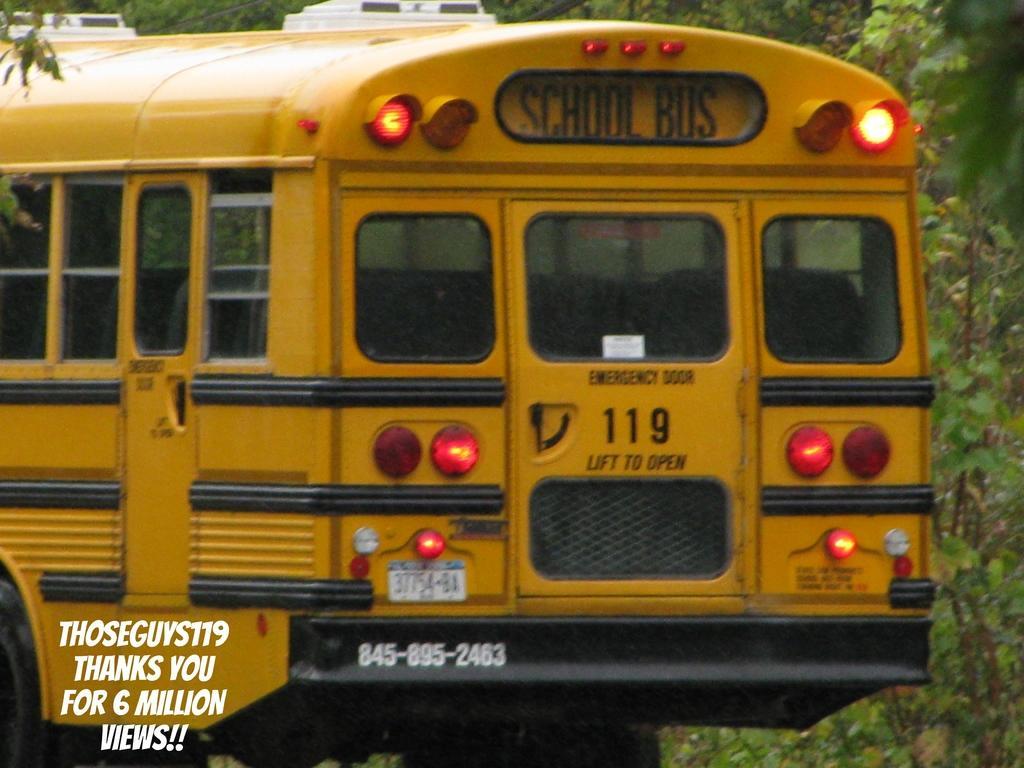Describe this image in one or two sentences. In the background we can see the trees. This picture is mainly highlighted with a yellow school bus. In the bottom left corner we can see the text. 